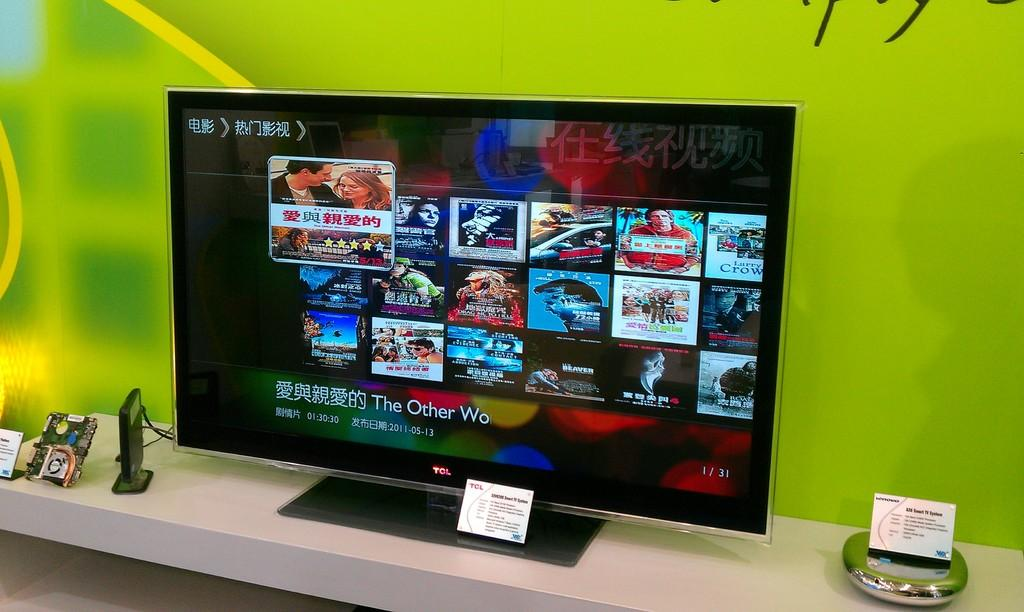Provide a one-sentence caption for the provided image. A card with the letters TCL is propped in front of a screen showing video selections. 